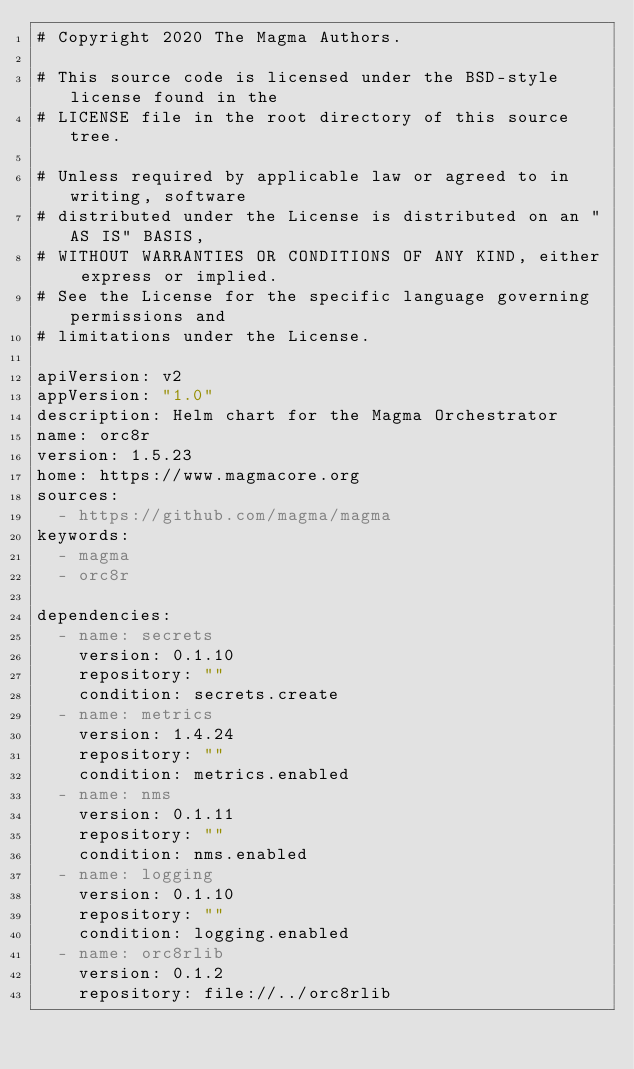Convert code to text. <code><loc_0><loc_0><loc_500><loc_500><_YAML_># Copyright 2020 The Magma Authors.

# This source code is licensed under the BSD-style license found in the
# LICENSE file in the root directory of this source tree.

# Unless required by applicable law or agreed to in writing, software
# distributed under the License is distributed on an "AS IS" BASIS,
# WITHOUT WARRANTIES OR CONDITIONS OF ANY KIND, either express or implied.
# See the License for the specific language governing permissions and
# limitations under the License.

apiVersion: v2
appVersion: "1.0"
description: Helm chart for the Magma Orchestrator
name: orc8r
version: 1.5.23
home: https://www.magmacore.org
sources:
  - https://github.com/magma/magma
keywords:
  - magma
  - orc8r

dependencies:
  - name: secrets
    version: 0.1.10
    repository: ""
    condition: secrets.create
  - name: metrics
    version: 1.4.24
    repository: ""
    condition: metrics.enabled
  - name: nms
    version: 0.1.11
    repository: ""
    condition: nms.enabled
  - name: logging
    version: 0.1.10
    repository: ""
    condition: logging.enabled
  - name: orc8rlib
    version: 0.1.2
    repository: file://../orc8rlib
</code> 